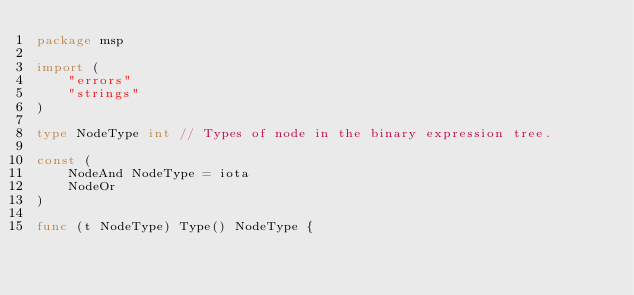Convert code to text. <code><loc_0><loc_0><loc_500><loc_500><_Go_>package msp

import (
	"errors"
	"strings"
)

type NodeType int // Types of node in the binary expression tree.

const (
	NodeAnd NodeType = iota
	NodeOr
)

func (t NodeType) Type() NodeType {</code> 